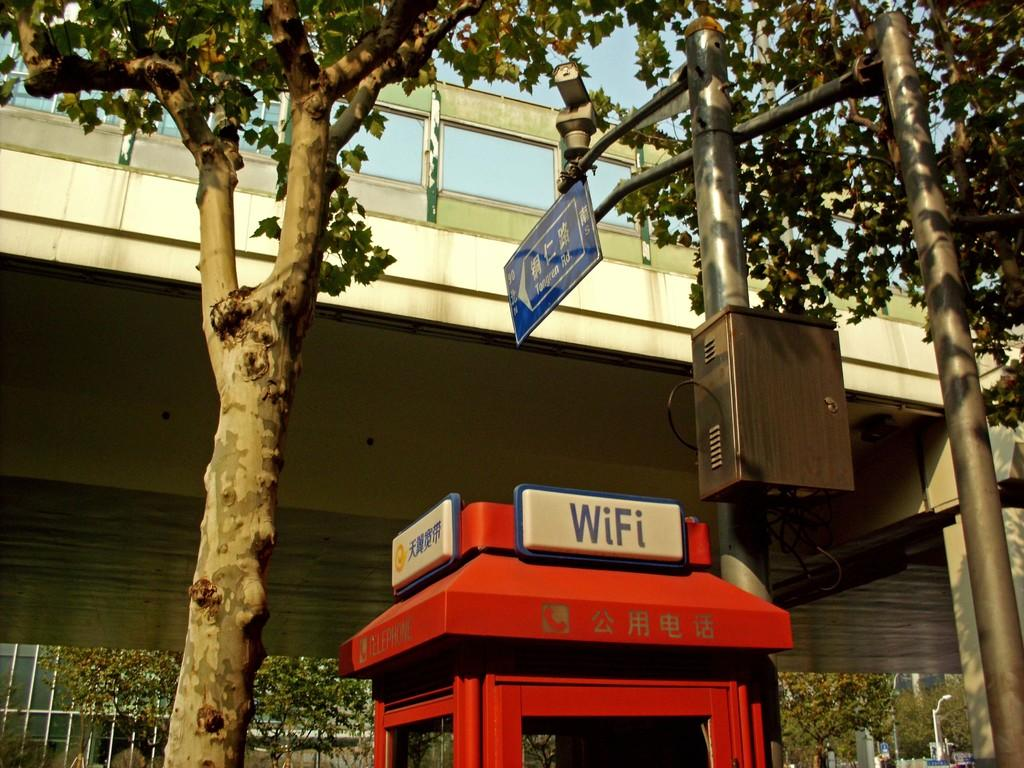Provide a one-sentence caption for the provided image. A red box has a sign that reads WiFi. 